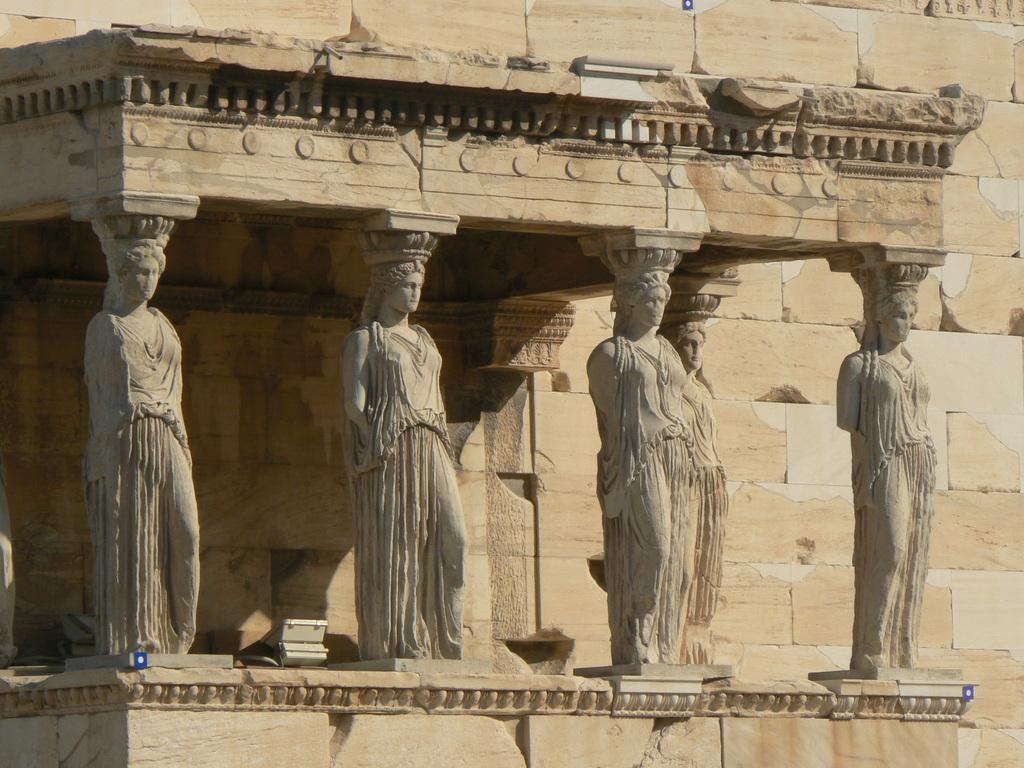Can you describe this image briefly? In this image we can see some statues which are attached to the wall and in the background of the image there is a wall. 